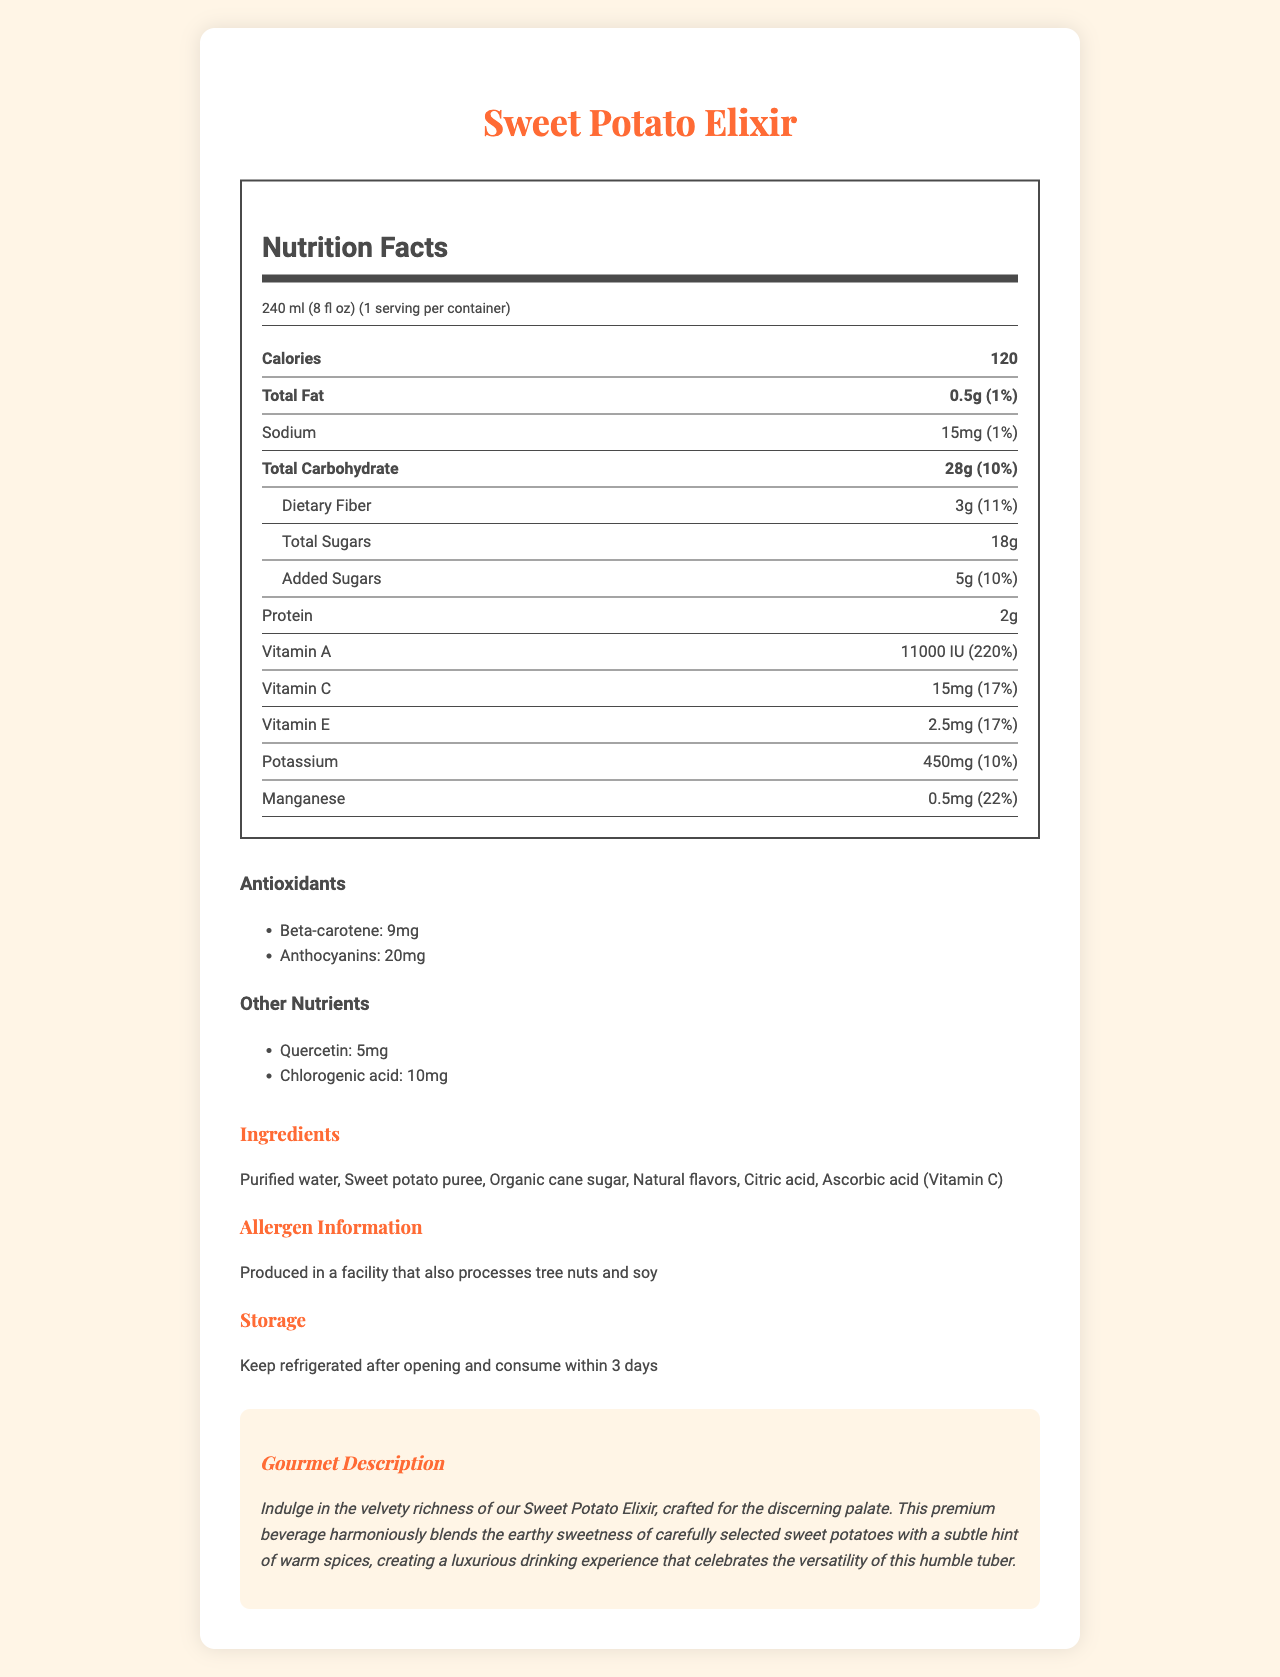what is the serving size of the Sweet Potato Elixir? The serving size is clearly mentioned at the top of the Nutrition Facts section.
Answer: 240 ml (8 fl oz) how many calories are in one serving of Sweet Potato Elixir? The calorie content is listed under the "Nutrition Facts" heading, specifically stating 120 calories.
Answer: 120 what is the amount of dietary fiber in the Sweet Potato Elixir? The dietary fiber amount is found under the "Total Carbohydrate" section, specifying 3g.
Answer: 3g what antioxidant amounts are present in the Sweet Potato Elixir? The antioxidants section lists Beta-carotene and Anthocyanins along with their respective amounts.
Answer: Beta-carotene: 9mg, Anthocyanins: 20mg how much potassium does one serving of Sweet Potato Elixir contain? The amount of potassium is listed toward the end of the nutrition list, indicating 450mg.
Answer: 450mg which one of the following vitamins has the highest daily value percentage in the Sweet Potato Elixir? A. Vitamin A B. Vitamin C C. Vitamin E D. Vitamin B Vitamin A has 220% daily value, which is the highest among the listed vitamins.
Answer: A. Vitamin A what type of information is available in the gourmet description of the Sweet Potato Elixir? 
A. Nutrient benefits 
B. Ingredients list 
C. Sensory experience 
D. Storage instructions The gourmet description details the sensory experience of drinking the Sweet Potato Elixir, highlighting its velvety richness and subtle spice notes.
Answer: C. Sensory experience is this beverage suitable for someone who has a tree nut allergy? The allergen information indicates that the product is produced in a facility that also processes tree nuts, making it potentially unsuitable for someone with a tree nut allergy.
Answer: No please summarize the main idea of this document. The document contains various sections, including serving size, nutritional facts, antioxidants, additional nutrients, ingredients, allergen information, storage instructions, and a gourmet description, providing a thorough overview of the Sweet Potato Elixir.
Answer: The main idea of the document is to provide comprehensive nutritional information, ingredients, allergen details, and a sensory description of the Sweet Potato Elixir, a premium beverage that emphasizes antioxidant and micronutrient content derived from sweet potatoes. how much quercetin is in one serving of the Sweet Potato Elixir? The "Other Nutrients" section lists the amount of quercetin as 5mg.
Answer: 5mg can you refrigerate the Sweet Potato Elixir after opening? The storage instructions clearly state to keep the beverage refrigerated after opening.
Answer: Yes how many servings are there per container of the Sweet Potato Elixir? The serving information indicates that there is 1 serving per container.
Answer: 1 what is the daily value percentage of manganese in one serving? The daily value percentage for manganese is listed towards the end of the nutrition facts.
Answer: 22% what natural flavors are included in the Sweet Potato Elixir? The ingredient list mentions "Natural flavors" but does not specify what those flavors are.
Answer: Not enough information 